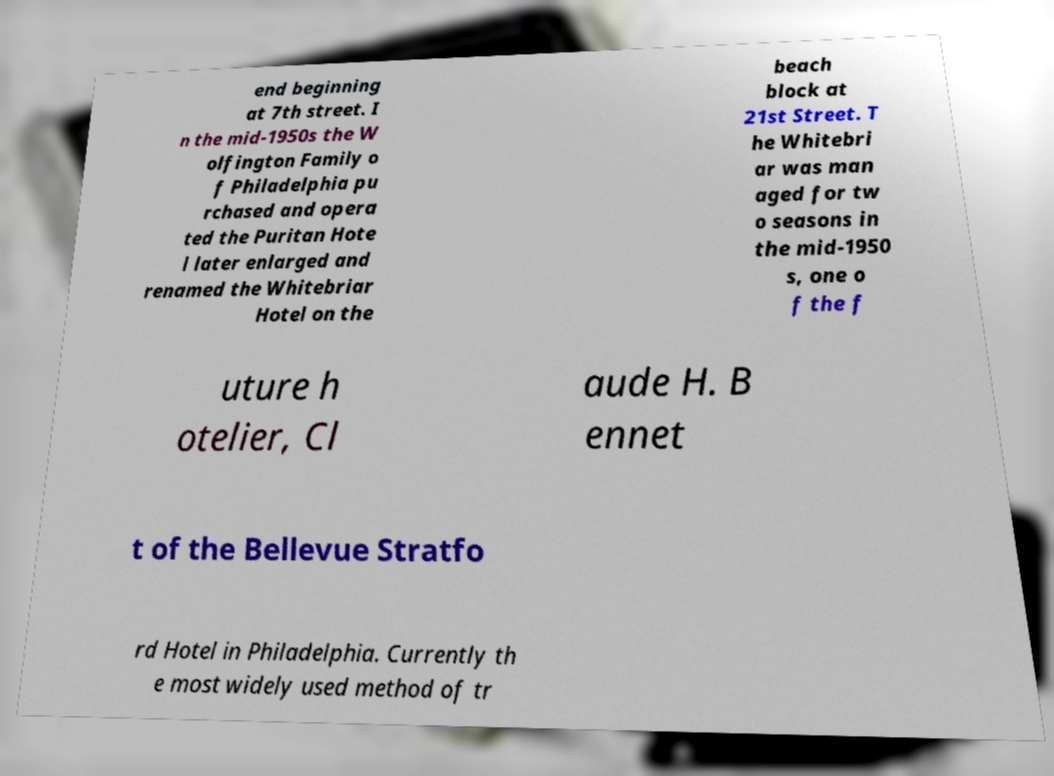What messages or text are displayed in this image? I need them in a readable, typed format. end beginning at 7th street. I n the mid-1950s the W olfington Family o f Philadelphia pu rchased and opera ted the Puritan Hote l later enlarged and renamed the Whitebriar Hotel on the beach block at 21st Street. T he Whitebri ar was man aged for tw o seasons in the mid-1950 s, one o f the f uture h otelier, Cl aude H. B ennet t of the Bellevue Stratfo rd Hotel in Philadelphia. Currently th e most widely used method of tr 